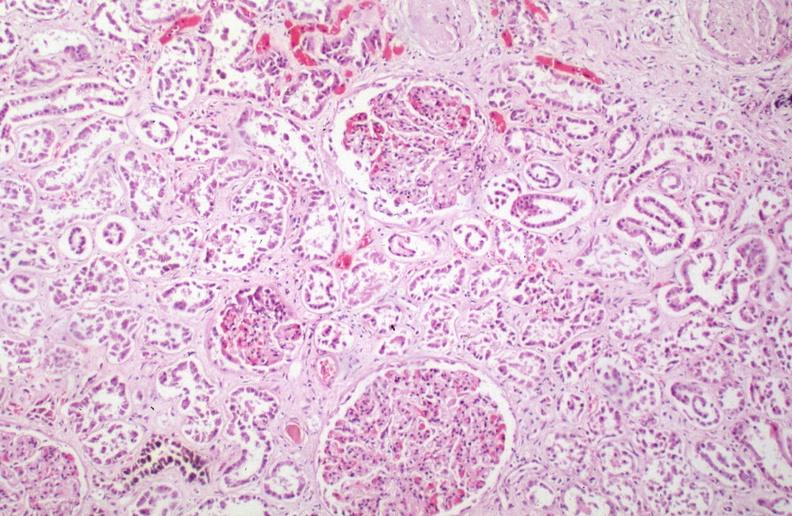s erythrophagocytosis new born caused by numerous blood transfusions?
Answer the question using a single word or phrase. No 